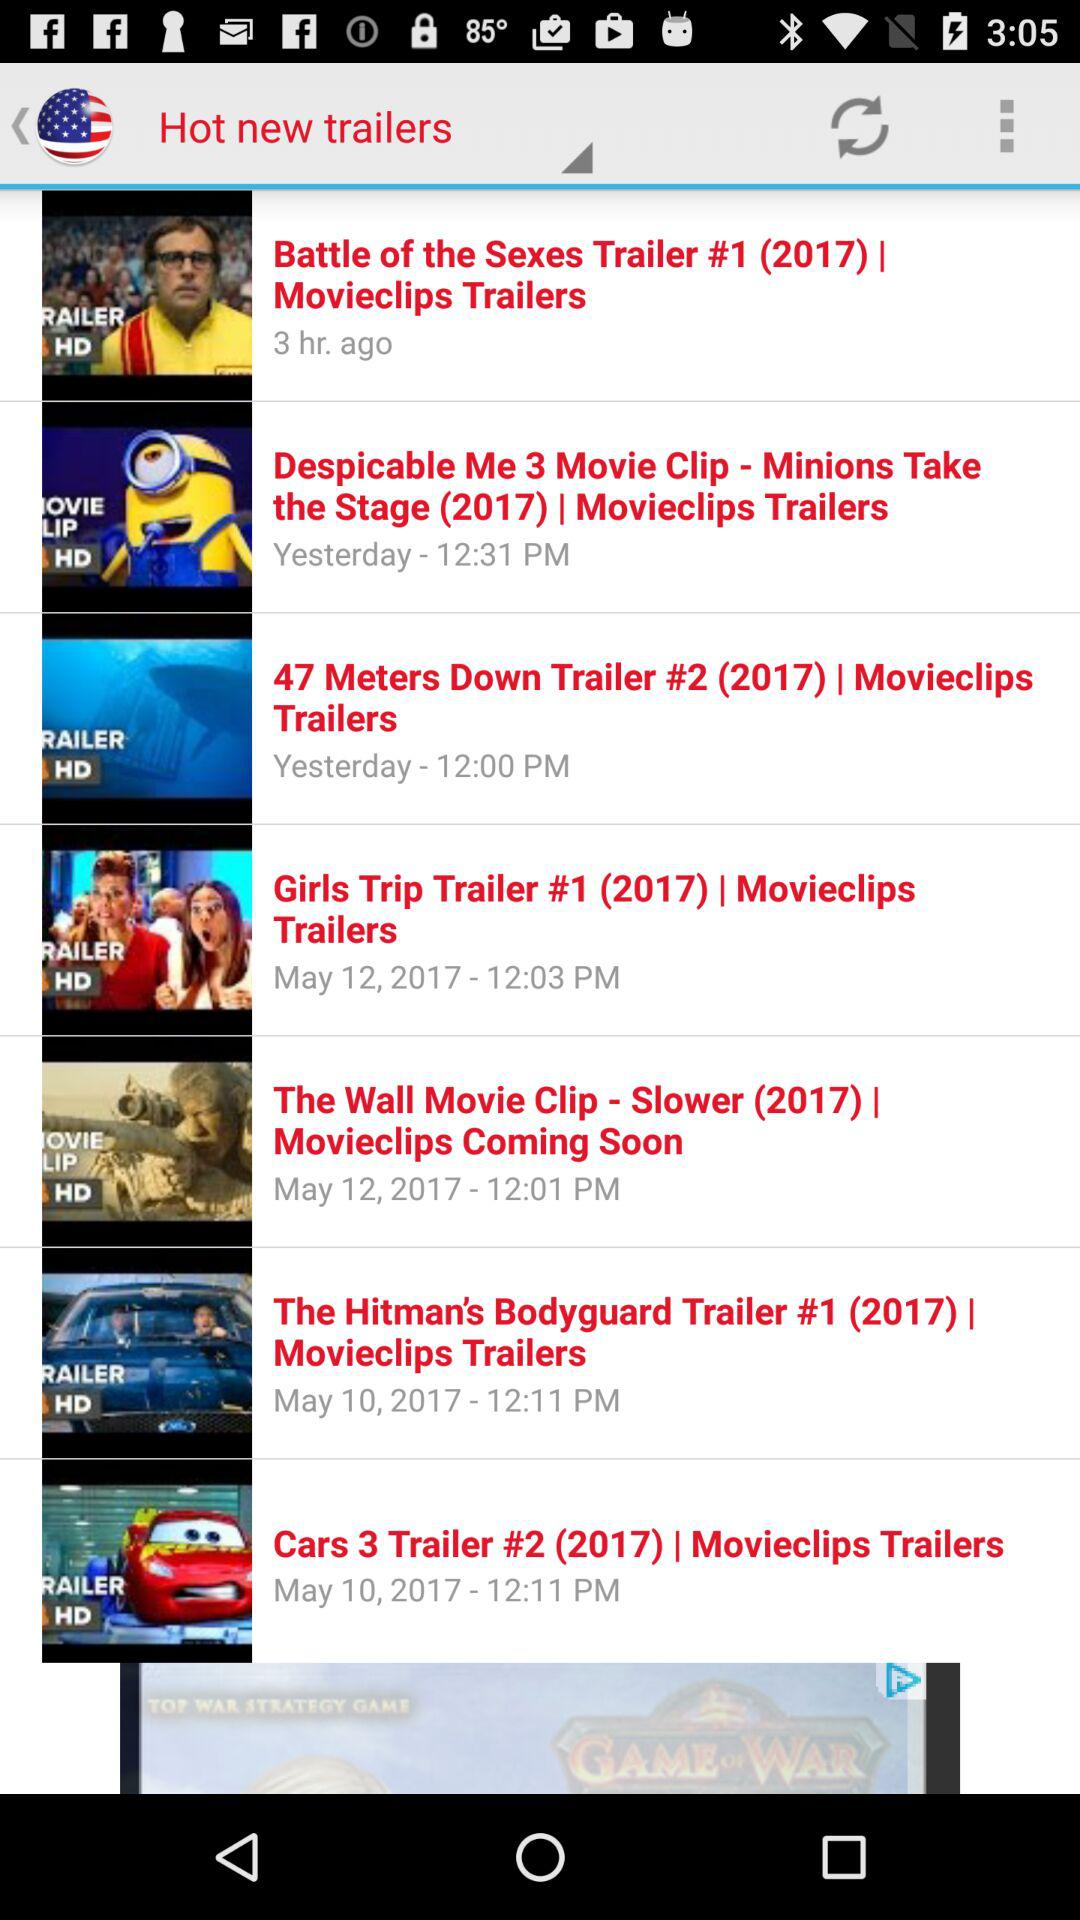When was the "Battle of the Sexes Trailer" posted? It was posted 3 hours ago. 